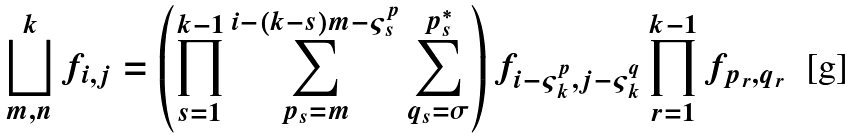Convert formula to latex. <formula><loc_0><loc_0><loc_500><loc_500>\bigsqcup _ { m , n } ^ { k } f _ { i , j } = \left ( \prod _ { s = 1 } ^ { k - 1 } \sum _ { p _ { s } = m } ^ { i - ( k - s ) m - \varsigma ^ { p } _ { s } } \sum _ { q _ { s } = \sigma } ^ { p _ { s } ^ { * } } \right ) f _ { i - \varsigma ^ { p } _ { k } , j - \varsigma ^ { q } _ { k } } \prod _ { r = 1 } ^ { k - 1 } f _ { p _ { r } , q _ { r } }</formula> 